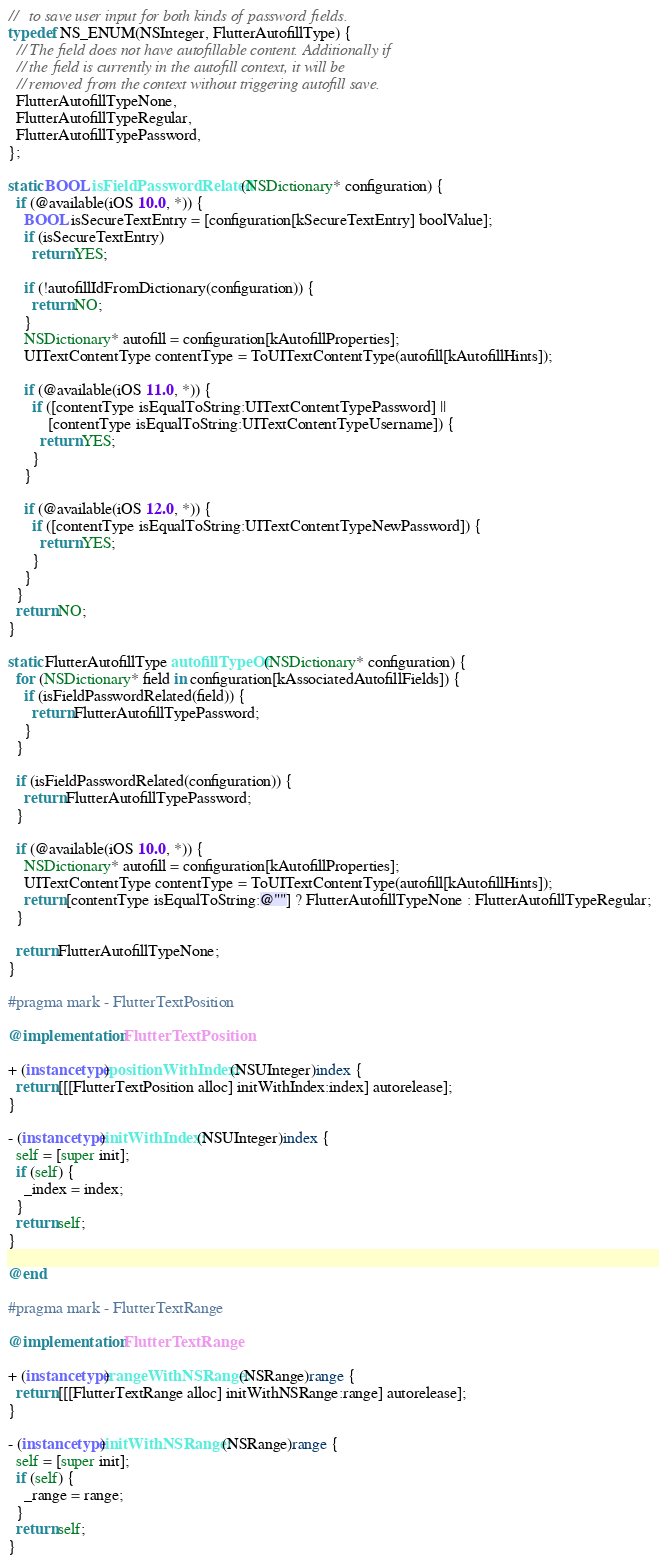Convert code to text. <code><loc_0><loc_0><loc_500><loc_500><_ObjectiveC_>//   to save user input for both kinds of password fields.
typedef NS_ENUM(NSInteger, FlutterAutofillType) {
  // The field does not have autofillable content. Additionally if
  // the field is currently in the autofill context, it will be
  // removed from the context without triggering autofill save.
  FlutterAutofillTypeNone,
  FlutterAutofillTypeRegular,
  FlutterAutofillTypePassword,
};

static BOOL isFieldPasswordRelated(NSDictionary* configuration) {
  if (@available(iOS 10.0, *)) {
    BOOL isSecureTextEntry = [configuration[kSecureTextEntry] boolValue];
    if (isSecureTextEntry)
      return YES;

    if (!autofillIdFromDictionary(configuration)) {
      return NO;
    }
    NSDictionary* autofill = configuration[kAutofillProperties];
    UITextContentType contentType = ToUITextContentType(autofill[kAutofillHints]);

    if (@available(iOS 11.0, *)) {
      if ([contentType isEqualToString:UITextContentTypePassword] ||
          [contentType isEqualToString:UITextContentTypeUsername]) {
        return YES;
      }
    }

    if (@available(iOS 12.0, *)) {
      if ([contentType isEqualToString:UITextContentTypeNewPassword]) {
        return YES;
      }
    }
  }
  return NO;
}

static FlutterAutofillType autofillTypeOf(NSDictionary* configuration) {
  for (NSDictionary* field in configuration[kAssociatedAutofillFields]) {
    if (isFieldPasswordRelated(field)) {
      return FlutterAutofillTypePassword;
    }
  }

  if (isFieldPasswordRelated(configuration)) {
    return FlutterAutofillTypePassword;
  }

  if (@available(iOS 10.0, *)) {
    NSDictionary* autofill = configuration[kAutofillProperties];
    UITextContentType contentType = ToUITextContentType(autofill[kAutofillHints]);
    return [contentType isEqualToString:@""] ? FlutterAutofillTypeNone : FlutterAutofillTypeRegular;
  }

  return FlutterAutofillTypeNone;
}

#pragma mark - FlutterTextPosition

@implementation FlutterTextPosition

+ (instancetype)positionWithIndex:(NSUInteger)index {
  return [[[FlutterTextPosition alloc] initWithIndex:index] autorelease];
}

- (instancetype)initWithIndex:(NSUInteger)index {
  self = [super init];
  if (self) {
    _index = index;
  }
  return self;
}

@end

#pragma mark - FlutterTextRange

@implementation FlutterTextRange

+ (instancetype)rangeWithNSRange:(NSRange)range {
  return [[[FlutterTextRange alloc] initWithNSRange:range] autorelease];
}

- (instancetype)initWithNSRange:(NSRange)range {
  self = [super init];
  if (self) {
    _range = range;
  }
  return self;
}
</code> 